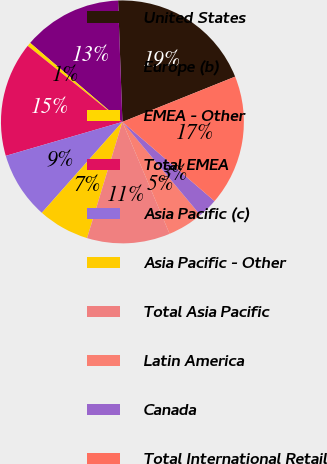Convert chart. <chart><loc_0><loc_0><loc_500><loc_500><pie_chart><fcel>United States<fcel>Europe (b)<fcel>EMEA - Other<fcel>Total EMEA<fcel>Asia Pacific (c)<fcel>Asia Pacific - Other<fcel>Total Asia Pacific<fcel>Latin America<fcel>Canada<fcel>Total International Retail<nl><fcel>19.49%<fcel>13.16%<fcel>0.51%<fcel>15.27%<fcel>8.95%<fcel>6.84%<fcel>11.05%<fcel>4.73%<fcel>2.62%<fcel>17.38%<nl></chart> 